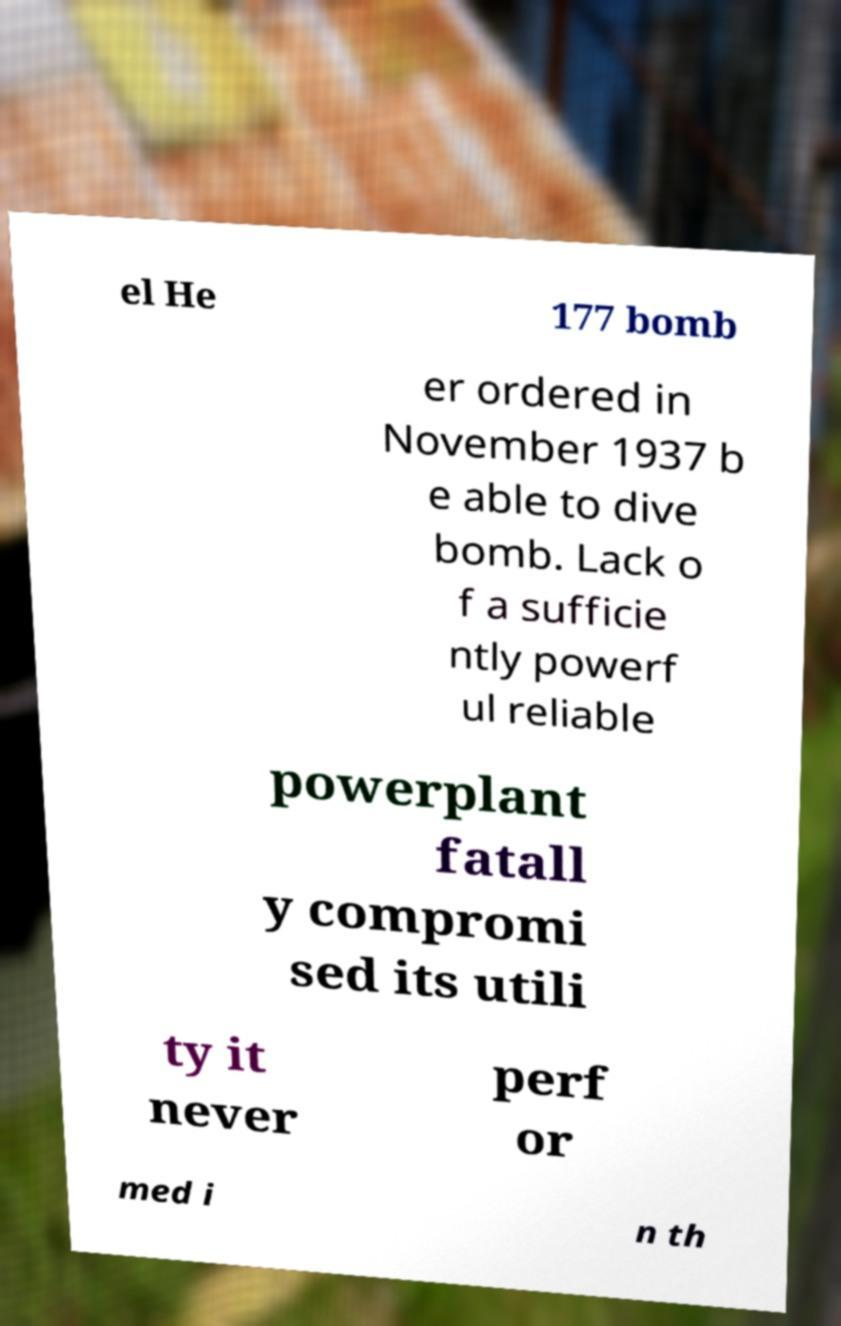Could you assist in decoding the text presented in this image and type it out clearly? el He 177 bomb er ordered in November 1937 b e able to dive bomb. Lack o f a sufficie ntly powerf ul reliable powerplant fatall y compromi sed its utili ty it never perf or med i n th 